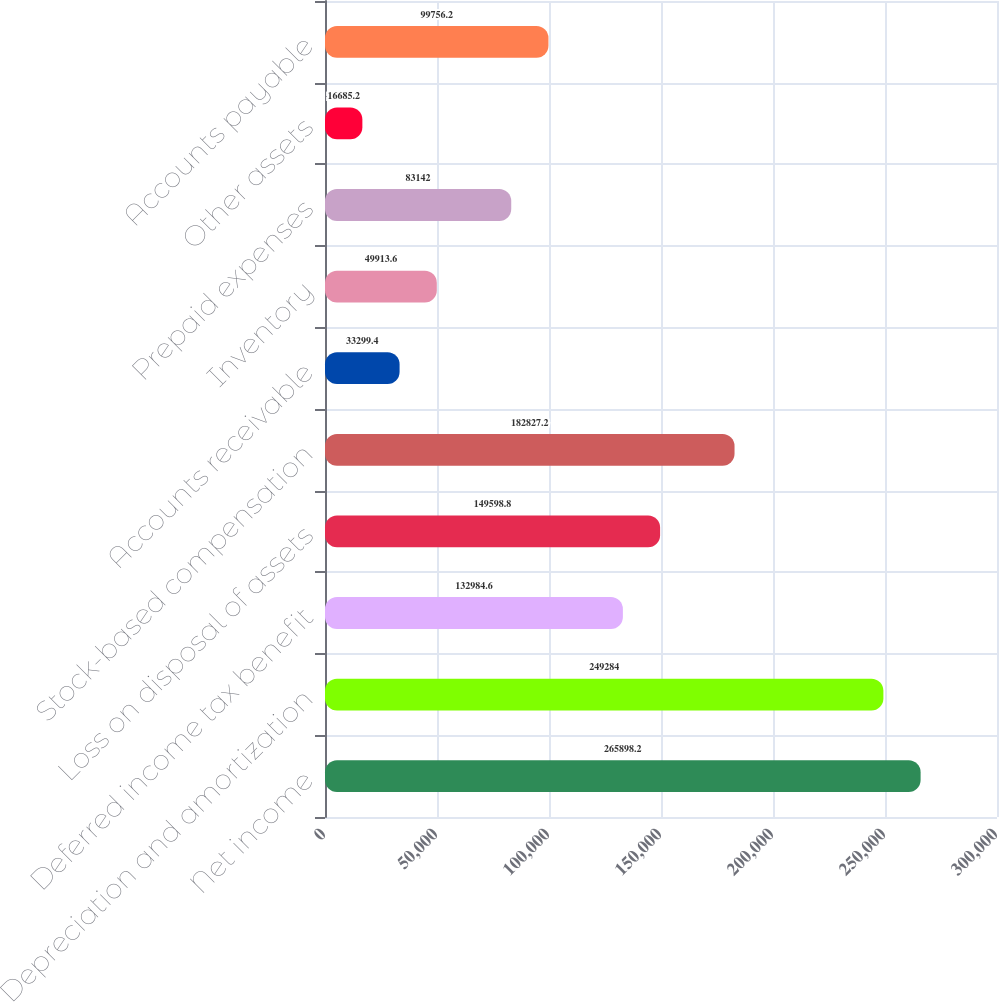<chart> <loc_0><loc_0><loc_500><loc_500><bar_chart><fcel>Net income<fcel>Depreciation and amortization<fcel>Deferred income tax benefit<fcel>Loss on disposal of assets<fcel>Stock-based compensation<fcel>Accounts receivable<fcel>Inventory<fcel>Prepaid expenses<fcel>Other assets<fcel>Accounts payable<nl><fcel>265898<fcel>249284<fcel>132985<fcel>149599<fcel>182827<fcel>33299.4<fcel>49913.6<fcel>83142<fcel>16685.2<fcel>99756.2<nl></chart> 